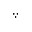<formula> <loc_0><loc_0><loc_500><loc_500>\because</formula> 